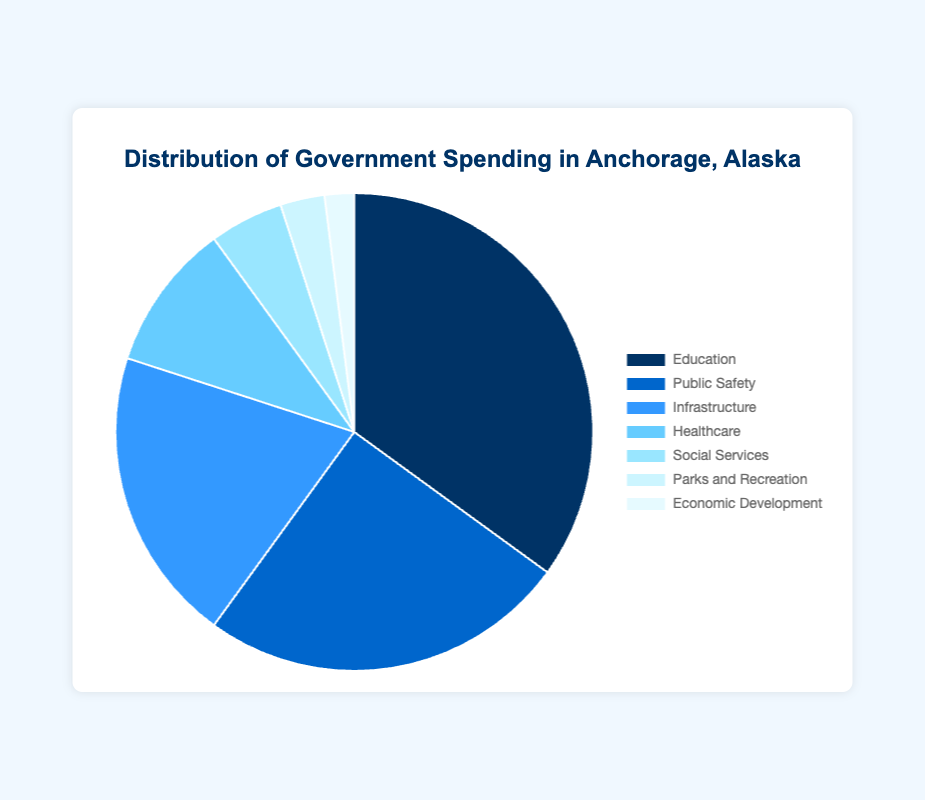What percentage of government spending is allocated to Healthcare and Social Services combined? To find the combined percentage, add the percentage of government spending allocated to Healthcare (10%) and Social Services (5%): 10% + 5% = 15%.
Answer: 15% Which sector receives the largest share of government spending? The sector with the highest percentage from the data is Education, which receives 35%.
Answer: Education How much more is spent on Public Safety compared to Economic Development? Subtract the percentage allocated to Economic Development (2%) from Public Safety (25%): 25% - 2% = 23%.
Answer: 23% Which two sectors together account for half of the government spending? Look for two sectors whose combined percentage equals approximately 50%. Education (35%) and Public Safety (25%) together total 60%, whereas Education (35%) and Infrastructure (20%) together total 55%, which is closer. However, for exactly half, Public Safety (25%) and Infrastructure (20%) together make 45%. Upon reevaluating, Education (35%) and Healthcare (10%) combined equals 45%. Hence, Education and Infrastructure combined is closest at 55%.
Answer: Education and Infrastructure What is the difference in spending between the sector with the third largest allocation and the sector with the smallest allocation? The third largest allocation is Infrastructure (20%), and the smallest allocation is Economic Development (2%). Subtract Economic Development from Infrastructure: 20% - 2% = 18%.
Answer: 18% List the sectors in order of decreasing allocation. The sectors ranked from highest to lowest allocation are: 1. Education (35%), 2. Public Safety (25%), 3. Infrastructure (20%), 4. Healthcare (10%), 5. Social Services (5%), 6. Parks and Recreation (3%), 7. Economic Development (2%).
Answer: Education, Public Safety, Infrastructure, Healthcare, Social Services, Parks and Recreation, Economic Development Which sectors together contribute less than the amount allocated to Infrastructure? Infrastructure gets 20%, so we need the combination of sectors totaling less than 20%. Adding the sectors with the smallest values: Economic Development (2%), Parks and Recreation (3%), and Social Services (5%) together make 10%. Adding Healthcare (10%) to 10% totals 20%, equal to Infrastructure. A combination of smaller sectors (Economic Development, Parks, and Social Services) actually falls below 20%.
Answer: Economic Development, Parks and Recreation, and Social Services If the city decided to double the allocation for Parks and Recreation, what would be the new percentage? Currently, Parks and Recreation is allocated 3%. Doubling this would result in: 3% * 2 = 6%.
Answer: 6% What percentage more is allocated to Education compared to Public Safety? Subtract the percentage for Public Safety (25%) from Education (35%): 35% - 25% = 10%.
Answer: 10% What are the lightest colored sectors in the pie chart? From the description, the lighter colors are used for the sectors with smaller allocations. The two lightest colored sectors based on their small percentage are Economic Development (2%) and Parks and Recreation (3%).
Answer: Economic Development and Parks and Recreation 